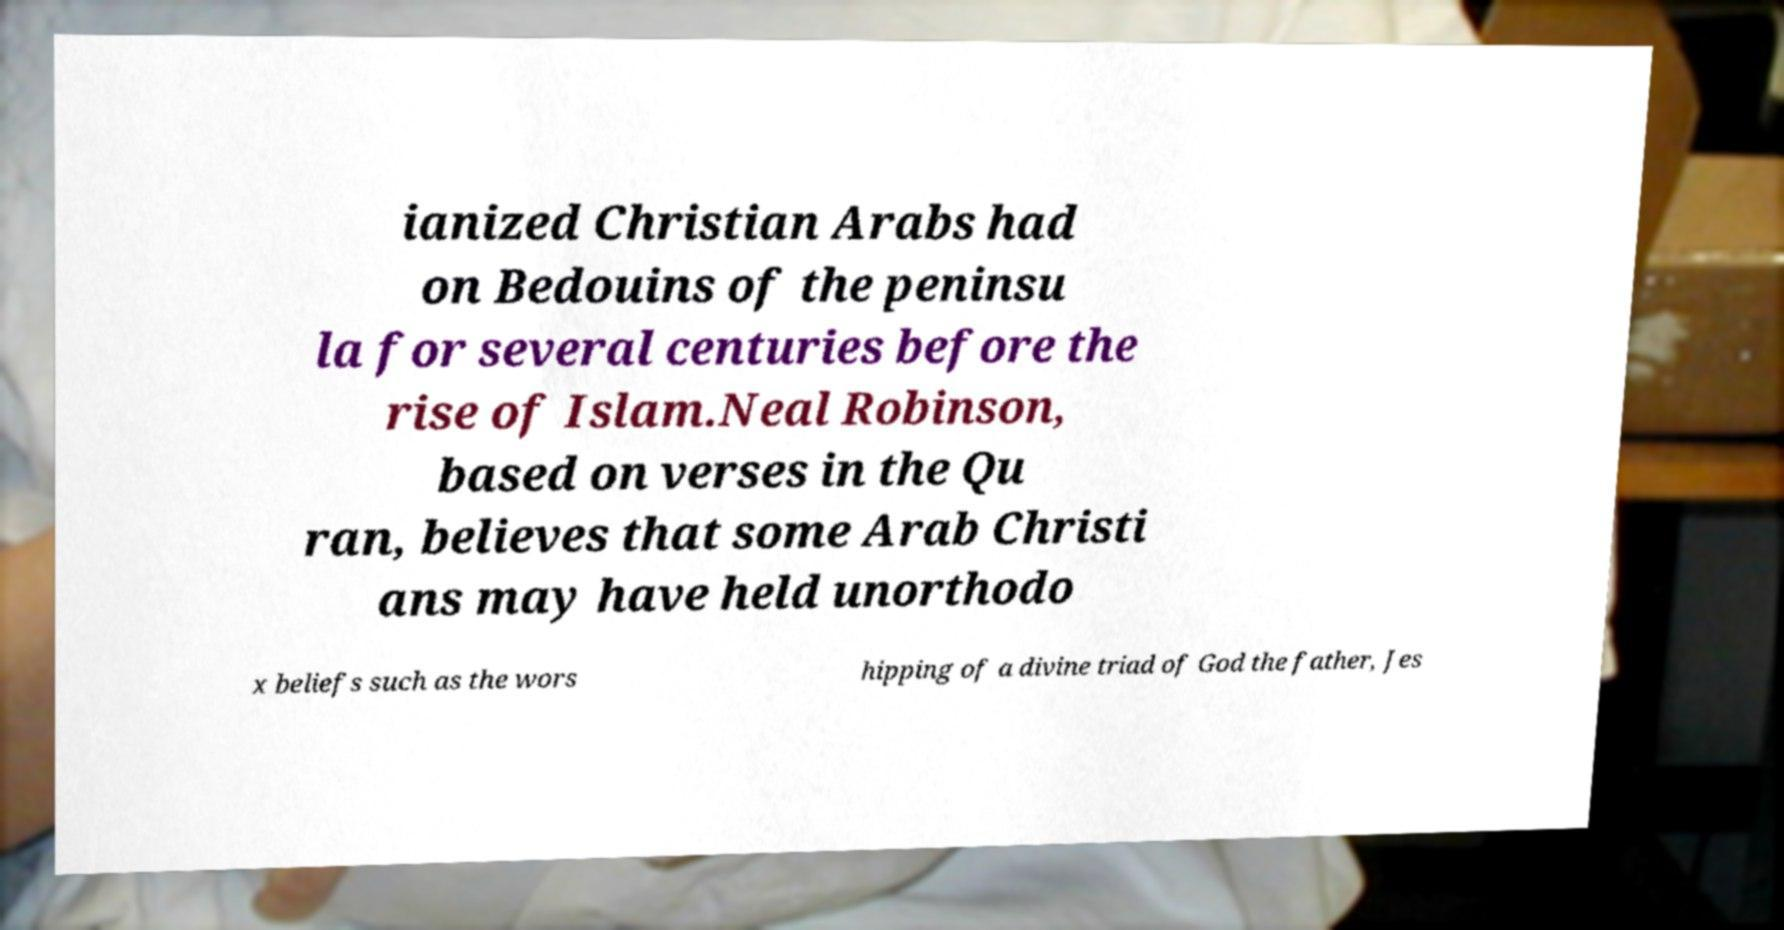What messages or text are displayed in this image? I need them in a readable, typed format. ianized Christian Arabs had on Bedouins of the peninsu la for several centuries before the rise of Islam.Neal Robinson, based on verses in the Qu ran, believes that some Arab Christi ans may have held unorthodo x beliefs such as the wors hipping of a divine triad of God the father, Jes 